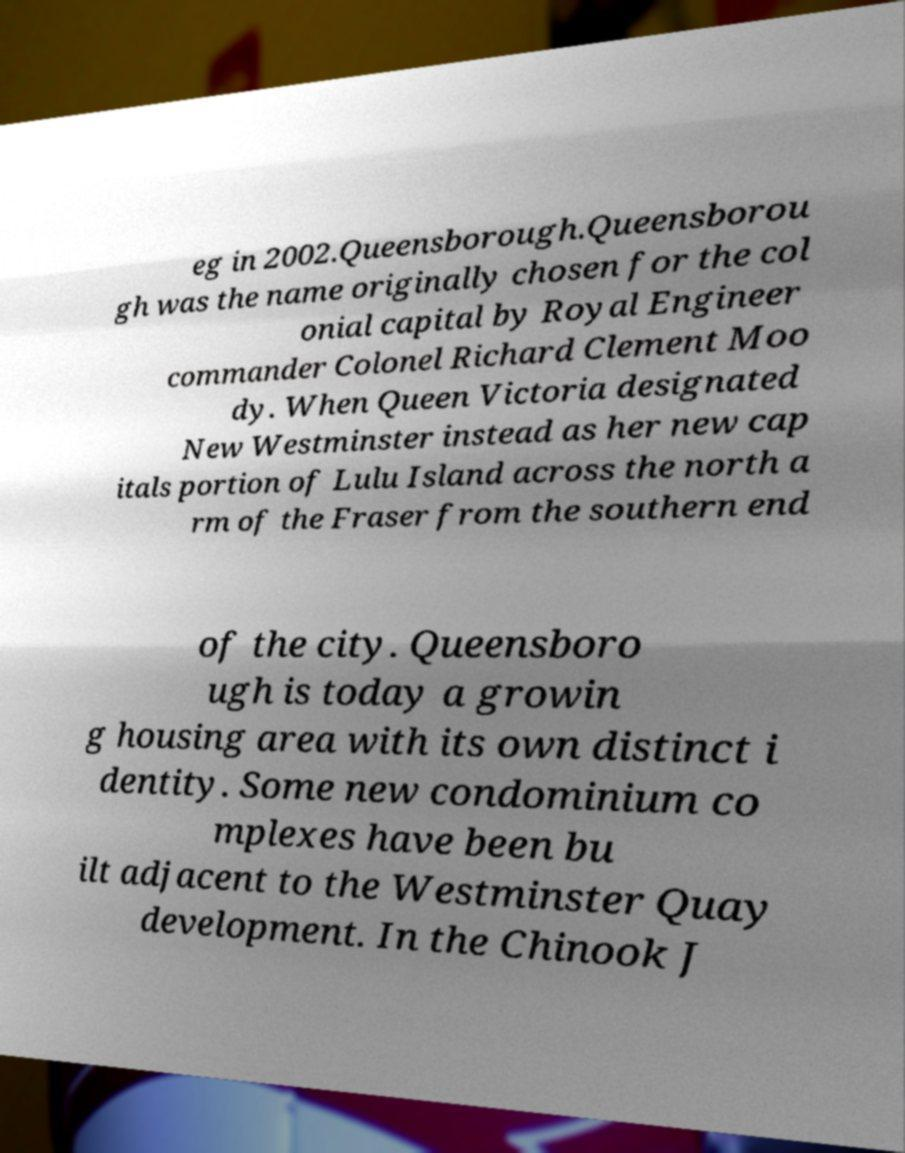For documentation purposes, I need the text within this image transcribed. Could you provide that? eg in 2002.Queensborough.Queensborou gh was the name originally chosen for the col onial capital by Royal Engineer commander Colonel Richard Clement Moo dy. When Queen Victoria designated New Westminster instead as her new cap itals portion of Lulu Island across the north a rm of the Fraser from the southern end of the city. Queensboro ugh is today a growin g housing area with its own distinct i dentity. Some new condominium co mplexes have been bu ilt adjacent to the Westminster Quay development. In the Chinook J 